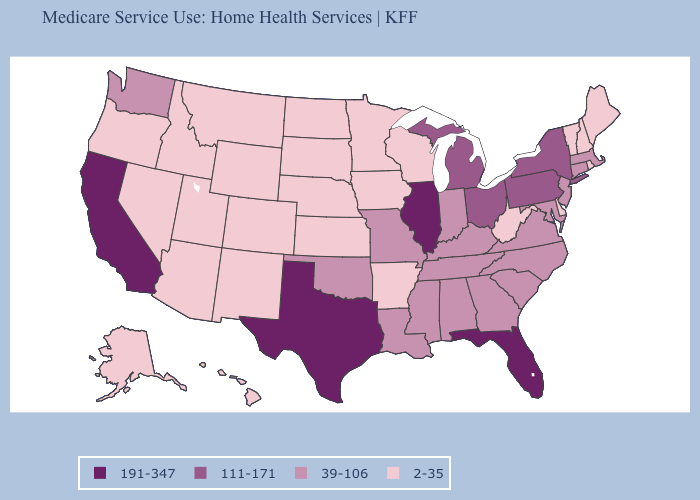Which states have the lowest value in the USA?
Write a very short answer. Alaska, Arizona, Arkansas, Colorado, Delaware, Hawaii, Idaho, Iowa, Kansas, Maine, Minnesota, Montana, Nebraska, Nevada, New Hampshire, New Mexico, North Dakota, Oregon, Rhode Island, South Dakota, Utah, Vermont, West Virginia, Wisconsin, Wyoming. Does New York have a lower value than Ohio?
Be succinct. No. What is the value of Oregon?
Be succinct. 2-35. Which states have the lowest value in the USA?
Answer briefly. Alaska, Arizona, Arkansas, Colorado, Delaware, Hawaii, Idaho, Iowa, Kansas, Maine, Minnesota, Montana, Nebraska, Nevada, New Hampshire, New Mexico, North Dakota, Oregon, Rhode Island, South Dakota, Utah, Vermont, West Virginia, Wisconsin, Wyoming. What is the value of Mississippi?
Keep it brief. 39-106. What is the value of Mississippi?
Short answer required. 39-106. Name the states that have a value in the range 2-35?
Quick response, please. Alaska, Arizona, Arkansas, Colorado, Delaware, Hawaii, Idaho, Iowa, Kansas, Maine, Minnesota, Montana, Nebraska, Nevada, New Hampshire, New Mexico, North Dakota, Oregon, Rhode Island, South Dakota, Utah, Vermont, West Virginia, Wisconsin, Wyoming. Name the states that have a value in the range 111-171?
Keep it brief. Michigan, New York, Ohio, Pennsylvania. Does the map have missing data?
Answer briefly. No. What is the value of New Hampshire?
Answer briefly. 2-35. What is the value of Delaware?
Short answer required. 2-35. Name the states that have a value in the range 2-35?
Answer briefly. Alaska, Arizona, Arkansas, Colorado, Delaware, Hawaii, Idaho, Iowa, Kansas, Maine, Minnesota, Montana, Nebraska, Nevada, New Hampshire, New Mexico, North Dakota, Oregon, Rhode Island, South Dakota, Utah, Vermont, West Virginia, Wisconsin, Wyoming. Name the states that have a value in the range 191-347?
Keep it brief. California, Florida, Illinois, Texas. Among the states that border Alabama , does Mississippi have the highest value?
Short answer required. No. Name the states that have a value in the range 191-347?
Keep it brief. California, Florida, Illinois, Texas. 